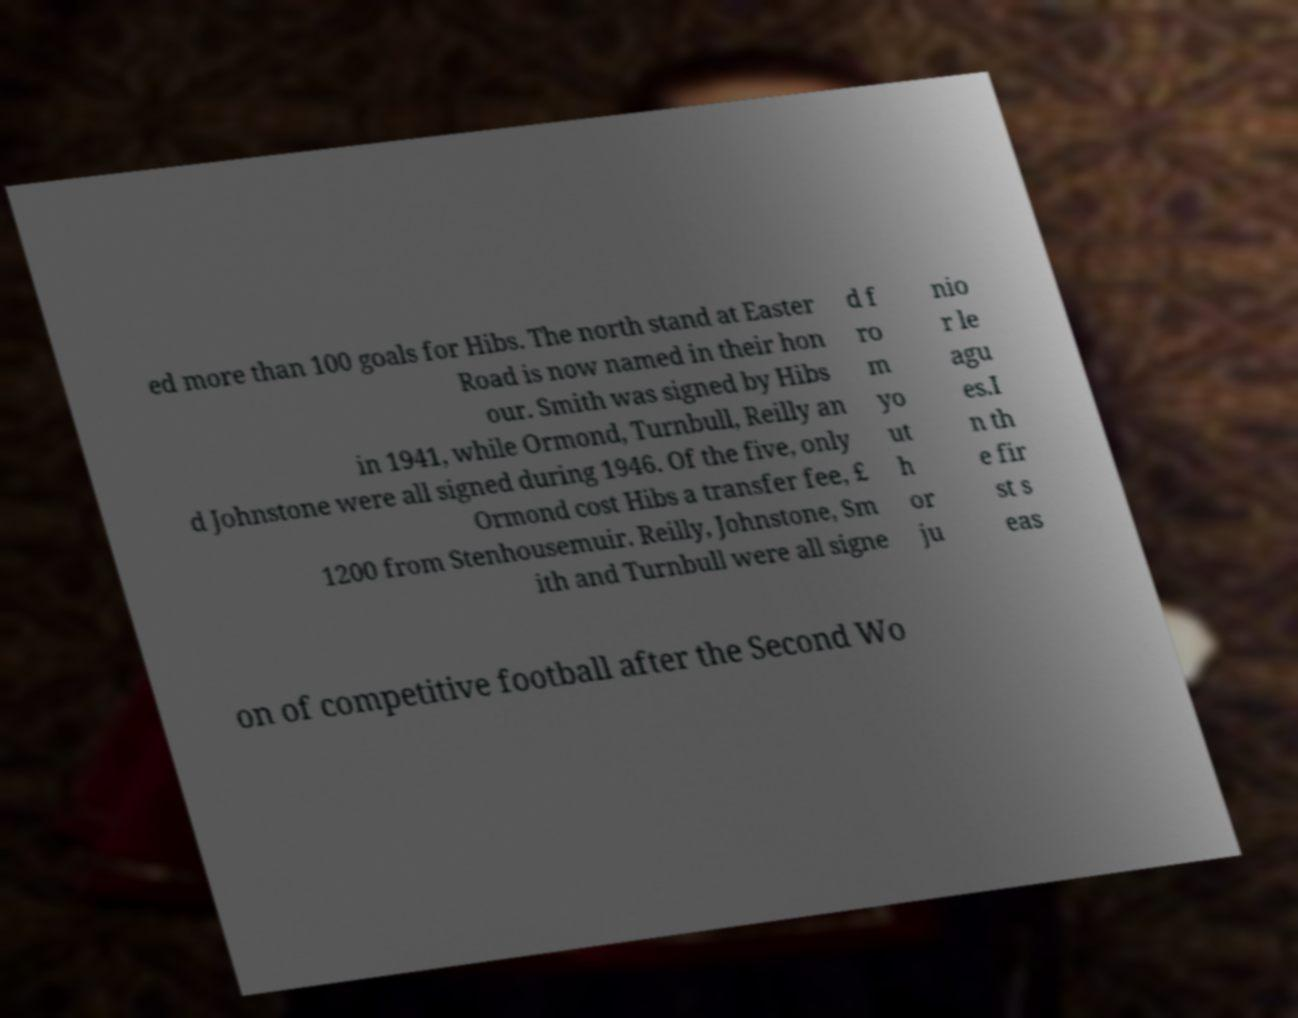What messages or text are displayed in this image? I need them in a readable, typed format. ed more than 100 goals for Hibs. The north stand at Easter Road is now named in their hon our. Smith was signed by Hibs in 1941, while Ormond, Turnbull, Reilly an d Johnstone were all signed during 1946. Of the five, only Ormond cost Hibs a transfer fee, £ 1200 from Stenhousemuir. Reilly, Johnstone, Sm ith and Turnbull were all signe d f ro m yo ut h or ju nio r le agu es.I n th e fir st s eas on of competitive football after the Second Wo 